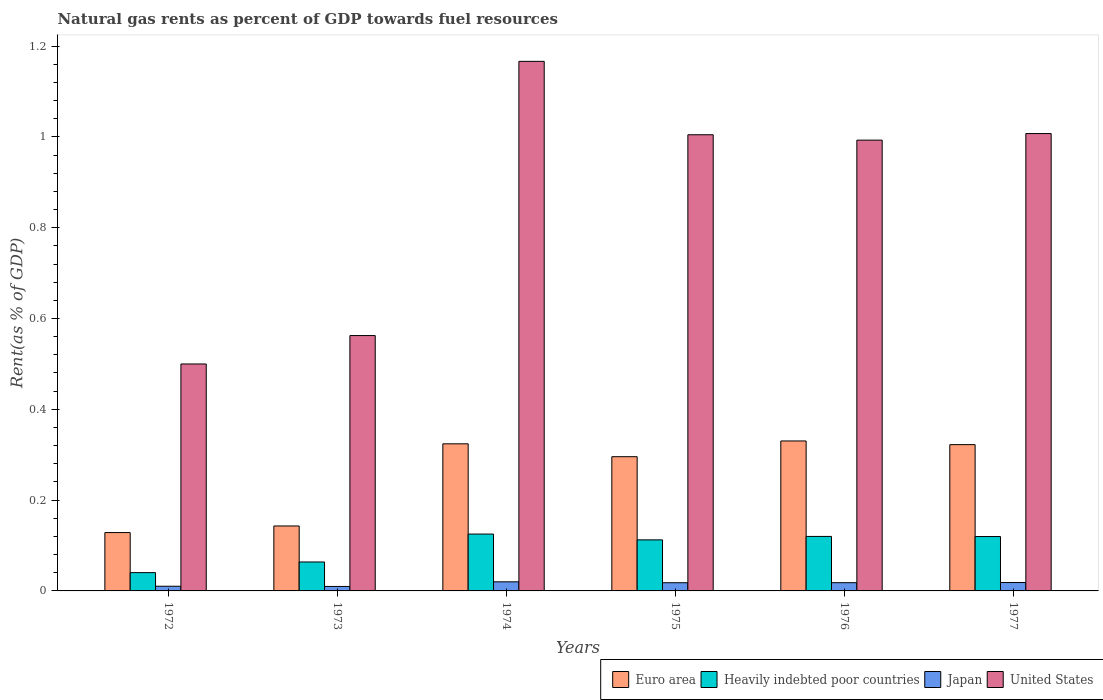How many different coloured bars are there?
Your response must be concise. 4. Are the number of bars per tick equal to the number of legend labels?
Your answer should be compact. Yes. Are the number of bars on each tick of the X-axis equal?
Provide a succinct answer. Yes. How many bars are there on the 3rd tick from the left?
Give a very brief answer. 4. What is the label of the 6th group of bars from the left?
Offer a terse response. 1977. In how many cases, is the number of bars for a given year not equal to the number of legend labels?
Provide a succinct answer. 0. What is the matural gas rent in Japan in 1975?
Your answer should be compact. 0.02. Across all years, what is the maximum matural gas rent in Japan?
Provide a succinct answer. 0.02. Across all years, what is the minimum matural gas rent in Japan?
Give a very brief answer. 0.01. In which year was the matural gas rent in Japan maximum?
Offer a terse response. 1974. In which year was the matural gas rent in Japan minimum?
Offer a very short reply. 1973. What is the total matural gas rent in Japan in the graph?
Ensure brevity in your answer.  0.09. What is the difference between the matural gas rent in Japan in 1972 and that in 1973?
Offer a very short reply. 0. What is the difference between the matural gas rent in Heavily indebted poor countries in 1974 and the matural gas rent in United States in 1972?
Offer a terse response. -0.37. What is the average matural gas rent in Heavily indebted poor countries per year?
Keep it short and to the point. 0.1. In the year 1972, what is the difference between the matural gas rent in Heavily indebted poor countries and matural gas rent in Japan?
Make the answer very short. 0.03. In how many years, is the matural gas rent in United States greater than 1.04 %?
Give a very brief answer. 1. What is the ratio of the matural gas rent in Euro area in 1973 to that in 1975?
Give a very brief answer. 0.48. Is the difference between the matural gas rent in Heavily indebted poor countries in 1973 and 1974 greater than the difference between the matural gas rent in Japan in 1973 and 1974?
Your answer should be compact. No. What is the difference between the highest and the second highest matural gas rent in Japan?
Give a very brief answer. 0. What is the difference between the highest and the lowest matural gas rent in Japan?
Ensure brevity in your answer.  0.01. Is it the case that in every year, the sum of the matural gas rent in Heavily indebted poor countries and matural gas rent in Japan is greater than the sum of matural gas rent in Euro area and matural gas rent in United States?
Offer a very short reply. Yes. What does the 2nd bar from the left in 1975 represents?
Ensure brevity in your answer.  Heavily indebted poor countries. Does the graph contain any zero values?
Your response must be concise. No. What is the title of the graph?
Your answer should be very brief. Natural gas rents as percent of GDP towards fuel resources. What is the label or title of the X-axis?
Ensure brevity in your answer.  Years. What is the label or title of the Y-axis?
Ensure brevity in your answer.  Rent(as % of GDP). What is the Rent(as % of GDP) of Euro area in 1972?
Your answer should be very brief. 0.13. What is the Rent(as % of GDP) in Heavily indebted poor countries in 1972?
Provide a succinct answer. 0.04. What is the Rent(as % of GDP) of Japan in 1972?
Your answer should be very brief. 0.01. What is the Rent(as % of GDP) of United States in 1972?
Provide a succinct answer. 0.5. What is the Rent(as % of GDP) of Euro area in 1973?
Offer a very short reply. 0.14. What is the Rent(as % of GDP) of Heavily indebted poor countries in 1973?
Provide a short and direct response. 0.06. What is the Rent(as % of GDP) of Japan in 1973?
Make the answer very short. 0.01. What is the Rent(as % of GDP) in United States in 1973?
Provide a succinct answer. 0.56. What is the Rent(as % of GDP) in Euro area in 1974?
Keep it short and to the point. 0.32. What is the Rent(as % of GDP) in Heavily indebted poor countries in 1974?
Your response must be concise. 0.13. What is the Rent(as % of GDP) in Japan in 1974?
Your answer should be very brief. 0.02. What is the Rent(as % of GDP) of United States in 1974?
Your response must be concise. 1.17. What is the Rent(as % of GDP) of Euro area in 1975?
Offer a very short reply. 0.3. What is the Rent(as % of GDP) in Heavily indebted poor countries in 1975?
Your response must be concise. 0.11. What is the Rent(as % of GDP) of Japan in 1975?
Your answer should be compact. 0.02. What is the Rent(as % of GDP) in United States in 1975?
Make the answer very short. 1. What is the Rent(as % of GDP) of Euro area in 1976?
Your answer should be compact. 0.33. What is the Rent(as % of GDP) of Heavily indebted poor countries in 1976?
Make the answer very short. 0.12. What is the Rent(as % of GDP) in Japan in 1976?
Give a very brief answer. 0.02. What is the Rent(as % of GDP) of United States in 1976?
Offer a very short reply. 0.99. What is the Rent(as % of GDP) of Euro area in 1977?
Your answer should be compact. 0.32. What is the Rent(as % of GDP) of Heavily indebted poor countries in 1977?
Your response must be concise. 0.12. What is the Rent(as % of GDP) in Japan in 1977?
Your response must be concise. 0.02. What is the Rent(as % of GDP) of United States in 1977?
Your answer should be compact. 1.01. Across all years, what is the maximum Rent(as % of GDP) in Euro area?
Ensure brevity in your answer.  0.33. Across all years, what is the maximum Rent(as % of GDP) of Heavily indebted poor countries?
Your answer should be very brief. 0.13. Across all years, what is the maximum Rent(as % of GDP) of Japan?
Make the answer very short. 0.02. Across all years, what is the maximum Rent(as % of GDP) in United States?
Provide a short and direct response. 1.17. Across all years, what is the minimum Rent(as % of GDP) in Euro area?
Offer a terse response. 0.13. Across all years, what is the minimum Rent(as % of GDP) in Heavily indebted poor countries?
Give a very brief answer. 0.04. Across all years, what is the minimum Rent(as % of GDP) in Japan?
Offer a terse response. 0.01. Across all years, what is the minimum Rent(as % of GDP) of United States?
Offer a terse response. 0.5. What is the total Rent(as % of GDP) in Euro area in the graph?
Your answer should be very brief. 1.54. What is the total Rent(as % of GDP) of Heavily indebted poor countries in the graph?
Keep it short and to the point. 0.58. What is the total Rent(as % of GDP) in Japan in the graph?
Your answer should be compact. 0.09. What is the total Rent(as % of GDP) in United States in the graph?
Your answer should be compact. 5.23. What is the difference between the Rent(as % of GDP) of Euro area in 1972 and that in 1973?
Ensure brevity in your answer.  -0.01. What is the difference between the Rent(as % of GDP) of Heavily indebted poor countries in 1972 and that in 1973?
Provide a short and direct response. -0.02. What is the difference between the Rent(as % of GDP) in United States in 1972 and that in 1973?
Your response must be concise. -0.06. What is the difference between the Rent(as % of GDP) of Euro area in 1972 and that in 1974?
Offer a terse response. -0.2. What is the difference between the Rent(as % of GDP) of Heavily indebted poor countries in 1972 and that in 1974?
Ensure brevity in your answer.  -0.09. What is the difference between the Rent(as % of GDP) in Japan in 1972 and that in 1974?
Your answer should be compact. -0.01. What is the difference between the Rent(as % of GDP) of United States in 1972 and that in 1974?
Make the answer very short. -0.67. What is the difference between the Rent(as % of GDP) in Euro area in 1972 and that in 1975?
Provide a succinct answer. -0.17. What is the difference between the Rent(as % of GDP) of Heavily indebted poor countries in 1972 and that in 1975?
Offer a terse response. -0.07. What is the difference between the Rent(as % of GDP) of Japan in 1972 and that in 1975?
Your answer should be compact. -0.01. What is the difference between the Rent(as % of GDP) in United States in 1972 and that in 1975?
Provide a short and direct response. -0.5. What is the difference between the Rent(as % of GDP) of Euro area in 1972 and that in 1976?
Your answer should be compact. -0.2. What is the difference between the Rent(as % of GDP) in Heavily indebted poor countries in 1972 and that in 1976?
Provide a succinct answer. -0.08. What is the difference between the Rent(as % of GDP) in Japan in 1972 and that in 1976?
Your response must be concise. -0.01. What is the difference between the Rent(as % of GDP) in United States in 1972 and that in 1976?
Make the answer very short. -0.49. What is the difference between the Rent(as % of GDP) in Euro area in 1972 and that in 1977?
Keep it short and to the point. -0.19. What is the difference between the Rent(as % of GDP) in Heavily indebted poor countries in 1972 and that in 1977?
Offer a very short reply. -0.08. What is the difference between the Rent(as % of GDP) in Japan in 1972 and that in 1977?
Your response must be concise. -0.01. What is the difference between the Rent(as % of GDP) of United States in 1972 and that in 1977?
Your response must be concise. -0.51. What is the difference between the Rent(as % of GDP) in Euro area in 1973 and that in 1974?
Your answer should be very brief. -0.18. What is the difference between the Rent(as % of GDP) of Heavily indebted poor countries in 1973 and that in 1974?
Your answer should be very brief. -0.06. What is the difference between the Rent(as % of GDP) in Japan in 1973 and that in 1974?
Your answer should be very brief. -0.01. What is the difference between the Rent(as % of GDP) of United States in 1973 and that in 1974?
Your response must be concise. -0.6. What is the difference between the Rent(as % of GDP) of Euro area in 1973 and that in 1975?
Provide a succinct answer. -0.15. What is the difference between the Rent(as % of GDP) of Heavily indebted poor countries in 1973 and that in 1975?
Provide a short and direct response. -0.05. What is the difference between the Rent(as % of GDP) of Japan in 1973 and that in 1975?
Provide a short and direct response. -0.01. What is the difference between the Rent(as % of GDP) of United States in 1973 and that in 1975?
Ensure brevity in your answer.  -0.44. What is the difference between the Rent(as % of GDP) of Euro area in 1973 and that in 1976?
Provide a short and direct response. -0.19. What is the difference between the Rent(as % of GDP) in Heavily indebted poor countries in 1973 and that in 1976?
Keep it short and to the point. -0.06. What is the difference between the Rent(as % of GDP) of Japan in 1973 and that in 1976?
Provide a succinct answer. -0.01. What is the difference between the Rent(as % of GDP) in United States in 1973 and that in 1976?
Ensure brevity in your answer.  -0.43. What is the difference between the Rent(as % of GDP) of Euro area in 1973 and that in 1977?
Make the answer very short. -0.18. What is the difference between the Rent(as % of GDP) in Heavily indebted poor countries in 1973 and that in 1977?
Make the answer very short. -0.06. What is the difference between the Rent(as % of GDP) in Japan in 1973 and that in 1977?
Provide a succinct answer. -0.01. What is the difference between the Rent(as % of GDP) of United States in 1973 and that in 1977?
Make the answer very short. -0.44. What is the difference between the Rent(as % of GDP) of Euro area in 1974 and that in 1975?
Offer a very short reply. 0.03. What is the difference between the Rent(as % of GDP) of Heavily indebted poor countries in 1974 and that in 1975?
Ensure brevity in your answer.  0.01. What is the difference between the Rent(as % of GDP) in Japan in 1974 and that in 1975?
Keep it short and to the point. 0. What is the difference between the Rent(as % of GDP) of United States in 1974 and that in 1975?
Ensure brevity in your answer.  0.16. What is the difference between the Rent(as % of GDP) in Euro area in 1974 and that in 1976?
Your answer should be very brief. -0.01. What is the difference between the Rent(as % of GDP) of Heavily indebted poor countries in 1974 and that in 1976?
Your response must be concise. 0.01. What is the difference between the Rent(as % of GDP) in Japan in 1974 and that in 1976?
Your answer should be very brief. 0. What is the difference between the Rent(as % of GDP) of United States in 1974 and that in 1976?
Your response must be concise. 0.17. What is the difference between the Rent(as % of GDP) in Euro area in 1974 and that in 1977?
Offer a terse response. 0. What is the difference between the Rent(as % of GDP) in Heavily indebted poor countries in 1974 and that in 1977?
Offer a very short reply. 0.01. What is the difference between the Rent(as % of GDP) in Japan in 1974 and that in 1977?
Your response must be concise. 0. What is the difference between the Rent(as % of GDP) of United States in 1974 and that in 1977?
Keep it short and to the point. 0.16. What is the difference between the Rent(as % of GDP) of Euro area in 1975 and that in 1976?
Ensure brevity in your answer.  -0.03. What is the difference between the Rent(as % of GDP) in Heavily indebted poor countries in 1975 and that in 1976?
Provide a succinct answer. -0.01. What is the difference between the Rent(as % of GDP) in United States in 1975 and that in 1976?
Your answer should be compact. 0.01. What is the difference between the Rent(as % of GDP) of Euro area in 1975 and that in 1977?
Ensure brevity in your answer.  -0.03. What is the difference between the Rent(as % of GDP) in Heavily indebted poor countries in 1975 and that in 1977?
Ensure brevity in your answer.  -0.01. What is the difference between the Rent(as % of GDP) in Japan in 1975 and that in 1977?
Your answer should be very brief. -0. What is the difference between the Rent(as % of GDP) of United States in 1975 and that in 1977?
Provide a short and direct response. -0. What is the difference between the Rent(as % of GDP) in Euro area in 1976 and that in 1977?
Your answer should be compact. 0.01. What is the difference between the Rent(as % of GDP) of Heavily indebted poor countries in 1976 and that in 1977?
Your answer should be compact. 0. What is the difference between the Rent(as % of GDP) in Japan in 1976 and that in 1977?
Provide a succinct answer. -0. What is the difference between the Rent(as % of GDP) in United States in 1976 and that in 1977?
Keep it short and to the point. -0.01. What is the difference between the Rent(as % of GDP) in Euro area in 1972 and the Rent(as % of GDP) in Heavily indebted poor countries in 1973?
Ensure brevity in your answer.  0.06. What is the difference between the Rent(as % of GDP) of Euro area in 1972 and the Rent(as % of GDP) of Japan in 1973?
Make the answer very short. 0.12. What is the difference between the Rent(as % of GDP) in Euro area in 1972 and the Rent(as % of GDP) in United States in 1973?
Your answer should be very brief. -0.43. What is the difference between the Rent(as % of GDP) of Heavily indebted poor countries in 1972 and the Rent(as % of GDP) of Japan in 1973?
Give a very brief answer. 0.03. What is the difference between the Rent(as % of GDP) in Heavily indebted poor countries in 1972 and the Rent(as % of GDP) in United States in 1973?
Your answer should be compact. -0.52. What is the difference between the Rent(as % of GDP) in Japan in 1972 and the Rent(as % of GDP) in United States in 1973?
Ensure brevity in your answer.  -0.55. What is the difference between the Rent(as % of GDP) in Euro area in 1972 and the Rent(as % of GDP) in Heavily indebted poor countries in 1974?
Provide a short and direct response. 0. What is the difference between the Rent(as % of GDP) of Euro area in 1972 and the Rent(as % of GDP) of Japan in 1974?
Keep it short and to the point. 0.11. What is the difference between the Rent(as % of GDP) of Euro area in 1972 and the Rent(as % of GDP) of United States in 1974?
Provide a short and direct response. -1.04. What is the difference between the Rent(as % of GDP) in Heavily indebted poor countries in 1972 and the Rent(as % of GDP) in Japan in 1974?
Provide a succinct answer. 0.02. What is the difference between the Rent(as % of GDP) of Heavily indebted poor countries in 1972 and the Rent(as % of GDP) of United States in 1974?
Offer a terse response. -1.13. What is the difference between the Rent(as % of GDP) of Japan in 1972 and the Rent(as % of GDP) of United States in 1974?
Provide a succinct answer. -1.16. What is the difference between the Rent(as % of GDP) of Euro area in 1972 and the Rent(as % of GDP) of Heavily indebted poor countries in 1975?
Make the answer very short. 0.02. What is the difference between the Rent(as % of GDP) in Euro area in 1972 and the Rent(as % of GDP) in Japan in 1975?
Provide a short and direct response. 0.11. What is the difference between the Rent(as % of GDP) of Euro area in 1972 and the Rent(as % of GDP) of United States in 1975?
Your response must be concise. -0.88. What is the difference between the Rent(as % of GDP) in Heavily indebted poor countries in 1972 and the Rent(as % of GDP) in Japan in 1975?
Your answer should be compact. 0.02. What is the difference between the Rent(as % of GDP) in Heavily indebted poor countries in 1972 and the Rent(as % of GDP) in United States in 1975?
Your answer should be very brief. -0.96. What is the difference between the Rent(as % of GDP) of Japan in 1972 and the Rent(as % of GDP) of United States in 1975?
Ensure brevity in your answer.  -0.99. What is the difference between the Rent(as % of GDP) of Euro area in 1972 and the Rent(as % of GDP) of Heavily indebted poor countries in 1976?
Keep it short and to the point. 0.01. What is the difference between the Rent(as % of GDP) in Euro area in 1972 and the Rent(as % of GDP) in Japan in 1976?
Ensure brevity in your answer.  0.11. What is the difference between the Rent(as % of GDP) of Euro area in 1972 and the Rent(as % of GDP) of United States in 1976?
Offer a terse response. -0.86. What is the difference between the Rent(as % of GDP) of Heavily indebted poor countries in 1972 and the Rent(as % of GDP) of Japan in 1976?
Make the answer very short. 0.02. What is the difference between the Rent(as % of GDP) in Heavily indebted poor countries in 1972 and the Rent(as % of GDP) in United States in 1976?
Keep it short and to the point. -0.95. What is the difference between the Rent(as % of GDP) of Japan in 1972 and the Rent(as % of GDP) of United States in 1976?
Provide a succinct answer. -0.98. What is the difference between the Rent(as % of GDP) in Euro area in 1972 and the Rent(as % of GDP) in Heavily indebted poor countries in 1977?
Give a very brief answer. 0.01. What is the difference between the Rent(as % of GDP) of Euro area in 1972 and the Rent(as % of GDP) of Japan in 1977?
Make the answer very short. 0.11. What is the difference between the Rent(as % of GDP) in Euro area in 1972 and the Rent(as % of GDP) in United States in 1977?
Make the answer very short. -0.88. What is the difference between the Rent(as % of GDP) in Heavily indebted poor countries in 1972 and the Rent(as % of GDP) in Japan in 1977?
Provide a short and direct response. 0.02. What is the difference between the Rent(as % of GDP) in Heavily indebted poor countries in 1972 and the Rent(as % of GDP) in United States in 1977?
Your answer should be compact. -0.97. What is the difference between the Rent(as % of GDP) in Japan in 1972 and the Rent(as % of GDP) in United States in 1977?
Your answer should be very brief. -1. What is the difference between the Rent(as % of GDP) of Euro area in 1973 and the Rent(as % of GDP) of Heavily indebted poor countries in 1974?
Offer a very short reply. 0.02. What is the difference between the Rent(as % of GDP) in Euro area in 1973 and the Rent(as % of GDP) in Japan in 1974?
Ensure brevity in your answer.  0.12. What is the difference between the Rent(as % of GDP) of Euro area in 1973 and the Rent(as % of GDP) of United States in 1974?
Offer a very short reply. -1.02. What is the difference between the Rent(as % of GDP) of Heavily indebted poor countries in 1973 and the Rent(as % of GDP) of Japan in 1974?
Your answer should be very brief. 0.04. What is the difference between the Rent(as % of GDP) of Heavily indebted poor countries in 1973 and the Rent(as % of GDP) of United States in 1974?
Your response must be concise. -1.1. What is the difference between the Rent(as % of GDP) of Japan in 1973 and the Rent(as % of GDP) of United States in 1974?
Offer a terse response. -1.16. What is the difference between the Rent(as % of GDP) of Euro area in 1973 and the Rent(as % of GDP) of Heavily indebted poor countries in 1975?
Give a very brief answer. 0.03. What is the difference between the Rent(as % of GDP) of Euro area in 1973 and the Rent(as % of GDP) of United States in 1975?
Provide a short and direct response. -0.86. What is the difference between the Rent(as % of GDP) of Heavily indebted poor countries in 1973 and the Rent(as % of GDP) of Japan in 1975?
Make the answer very short. 0.05. What is the difference between the Rent(as % of GDP) in Heavily indebted poor countries in 1973 and the Rent(as % of GDP) in United States in 1975?
Your answer should be compact. -0.94. What is the difference between the Rent(as % of GDP) in Japan in 1973 and the Rent(as % of GDP) in United States in 1975?
Ensure brevity in your answer.  -0.99. What is the difference between the Rent(as % of GDP) in Euro area in 1973 and the Rent(as % of GDP) in Heavily indebted poor countries in 1976?
Your response must be concise. 0.02. What is the difference between the Rent(as % of GDP) of Euro area in 1973 and the Rent(as % of GDP) of Japan in 1976?
Provide a succinct answer. 0.12. What is the difference between the Rent(as % of GDP) in Euro area in 1973 and the Rent(as % of GDP) in United States in 1976?
Keep it short and to the point. -0.85. What is the difference between the Rent(as % of GDP) of Heavily indebted poor countries in 1973 and the Rent(as % of GDP) of Japan in 1976?
Give a very brief answer. 0.05. What is the difference between the Rent(as % of GDP) of Heavily indebted poor countries in 1973 and the Rent(as % of GDP) of United States in 1976?
Keep it short and to the point. -0.93. What is the difference between the Rent(as % of GDP) in Japan in 1973 and the Rent(as % of GDP) in United States in 1976?
Give a very brief answer. -0.98. What is the difference between the Rent(as % of GDP) in Euro area in 1973 and the Rent(as % of GDP) in Heavily indebted poor countries in 1977?
Your response must be concise. 0.02. What is the difference between the Rent(as % of GDP) in Euro area in 1973 and the Rent(as % of GDP) in Japan in 1977?
Provide a succinct answer. 0.12. What is the difference between the Rent(as % of GDP) of Euro area in 1973 and the Rent(as % of GDP) of United States in 1977?
Your response must be concise. -0.86. What is the difference between the Rent(as % of GDP) in Heavily indebted poor countries in 1973 and the Rent(as % of GDP) in Japan in 1977?
Give a very brief answer. 0.05. What is the difference between the Rent(as % of GDP) of Heavily indebted poor countries in 1973 and the Rent(as % of GDP) of United States in 1977?
Your answer should be very brief. -0.94. What is the difference between the Rent(as % of GDP) in Japan in 1973 and the Rent(as % of GDP) in United States in 1977?
Give a very brief answer. -1. What is the difference between the Rent(as % of GDP) in Euro area in 1974 and the Rent(as % of GDP) in Heavily indebted poor countries in 1975?
Offer a terse response. 0.21. What is the difference between the Rent(as % of GDP) of Euro area in 1974 and the Rent(as % of GDP) of Japan in 1975?
Your answer should be very brief. 0.31. What is the difference between the Rent(as % of GDP) in Euro area in 1974 and the Rent(as % of GDP) in United States in 1975?
Give a very brief answer. -0.68. What is the difference between the Rent(as % of GDP) in Heavily indebted poor countries in 1974 and the Rent(as % of GDP) in Japan in 1975?
Provide a short and direct response. 0.11. What is the difference between the Rent(as % of GDP) in Heavily indebted poor countries in 1974 and the Rent(as % of GDP) in United States in 1975?
Make the answer very short. -0.88. What is the difference between the Rent(as % of GDP) in Japan in 1974 and the Rent(as % of GDP) in United States in 1975?
Provide a short and direct response. -0.98. What is the difference between the Rent(as % of GDP) of Euro area in 1974 and the Rent(as % of GDP) of Heavily indebted poor countries in 1976?
Give a very brief answer. 0.2. What is the difference between the Rent(as % of GDP) in Euro area in 1974 and the Rent(as % of GDP) in Japan in 1976?
Provide a short and direct response. 0.31. What is the difference between the Rent(as % of GDP) of Euro area in 1974 and the Rent(as % of GDP) of United States in 1976?
Make the answer very short. -0.67. What is the difference between the Rent(as % of GDP) of Heavily indebted poor countries in 1974 and the Rent(as % of GDP) of Japan in 1976?
Your answer should be very brief. 0.11. What is the difference between the Rent(as % of GDP) in Heavily indebted poor countries in 1974 and the Rent(as % of GDP) in United States in 1976?
Keep it short and to the point. -0.87. What is the difference between the Rent(as % of GDP) in Japan in 1974 and the Rent(as % of GDP) in United States in 1976?
Provide a succinct answer. -0.97. What is the difference between the Rent(as % of GDP) of Euro area in 1974 and the Rent(as % of GDP) of Heavily indebted poor countries in 1977?
Give a very brief answer. 0.2. What is the difference between the Rent(as % of GDP) of Euro area in 1974 and the Rent(as % of GDP) of Japan in 1977?
Provide a short and direct response. 0.31. What is the difference between the Rent(as % of GDP) of Euro area in 1974 and the Rent(as % of GDP) of United States in 1977?
Provide a short and direct response. -0.68. What is the difference between the Rent(as % of GDP) in Heavily indebted poor countries in 1974 and the Rent(as % of GDP) in Japan in 1977?
Keep it short and to the point. 0.11. What is the difference between the Rent(as % of GDP) in Heavily indebted poor countries in 1974 and the Rent(as % of GDP) in United States in 1977?
Provide a succinct answer. -0.88. What is the difference between the Rent(as % of GDP) of Japan in 1974 and the Rent(as % of GDP) of United States in 1977?
Your response must be concise. -0.99. What is the difference between the Rent(as % of GDP) of Euro area in 1975 and the Rent(as % of GDP) of Heavily indebted poor countries in 1976?
Your answer should be very brief. 0.18. What is the difference between the Rent(as % of GDP) in Euro area in 1975 and the Rent(as % of GDP) in Japan in 1976?
Provide a short and direct response. 0.28. What is the difference between the Rent(as % of GDP) of Euro area in 1975 and the Rent(as % of GDP) of United States in 1976?
Provide a succinct answer. -0.7. What is the difference between the Rent(as % of GDP) of Heavily indebted poor countries in 1975 and the Rent(as % of GDP) of Japan in 1976?
Your answer should be very brief. 0.09. What is the difference between the Rent(as % of GDP) in Heavily indebted poor countries in 1975 and the Rent(as % of GDP) in United States in 1976?
Provide a succinct answer. -0.88. What is the difference between the Rent(as % of GDP) of Japan in 1975 and the Rent(as % of GDP) of United States in 1976?
Offer a very short reply. -0.97. What is the difference between the Rent(as % of GDP) of Euro area in 1975 and the Rent(as % of GDP) of Heavily indebted poor countries in 1977?
Provide a short and direct response. 0.18. What is the difference between the Rent(as % of GDP) in Euro area in 1975 and the Rent(as % of GDP) in Japan in 1977?
Your answer should be compact. 0.28. What is the difference between the Rent(as % of GDP) in Euro area in 1975 and the Rent(as % of GDP) in United States in 1977?
Ensure brevity in your answer.  -0.71. What is the difference between the Rent(as % of GDP) in Heavily indebted poor countries in 1975 and the Rent(as % of GDP) in Japan in 1977?
Give a very brief answer. 0.09. What is the difference between the Rent(as % of GDP) of Heavily indebted poor countries in 1975 and the Rent(as % of GDP) of United States in 1977?
Provide a succinct answer. -0.89. What is the difference between the Rent(as % of GDP) of Japan in 1975 and the Rent(as % of GDP) of United States in 1977?
Make the answer very short. -0.99. What is the difference between the Rent(as % of GDP) in Euro area in 1976 and the Rent(as % of GDP) in Heavily indebted poor countries in 1977?
Make the answer very short. 0.21. What is the difference between the Rent(as % of GDP) of Euro area in 1976 and the Rent(as % of GDP) of Japan in 1977?
Offer a very short reply. 0.31. What is the difference between the Rent(as % of GDP) of Euro area in 1976 and the Rent(as % of GDP) of United States in 1977?
Offer a very short reply. -0.68. What is the difference between the Rent(as % of GDP) in Heavily indebted poor countries in 1976 and the Rent(as % of GDP) in Japan in 1977?
Make the answer very short. 0.1. What is the difference between the Rent(as % of GDP) in Heavily indebted poor countries in 1976 and the Rent(as % of GDP) in United States in 1977?
Provide a succinct answer. -0.89. What is the difference between the Rent(as % of GDP) of Japan in 1976 and the Rent(as % of GDP) of United States in 1977?
Offer a terse response. -0.99. What is the average Rent(as % of GDP) in Euro area per year?
Keep it short and to the point. 0.26. What is the average Rent(as % of GDP) of Heavily indebted poor countries per year?
Give a very brief answer. 0.1. What is the average Rent(as % of GDP) in Japan per year?
Your response must be concise. 0.02. What is the average Rent(as % of GDP) in United States per year?
Your answer should be compact. 0.87. In the year 1972, what is the difference between the Rent(as % of GDP) in Euro area and Rent(as % of GDP) in Heavily indebted poor countries?
Ensure brevity in your answer.  0.09. In the year 1972, what is the difference between the Rent(as % of GDP) of Euro area and Rent(as % of GDP) of Japan?
Your answer should be very brief. 0.12. In the year 1972, what is the difference between the Rent(as % of GDP) in Euro area and Rent(as % of GDP) in United States?
Give a very brief answer. -0.37. In the year 1972, what is the difference between the Rent(as % of GDP) in Heavily indebted poor countries and Rent(as % of GDP) in Japan?
Provide a short and direct response. 0.03. In the year 1972, what is the difference between the Rent(as % of GDP) in Heavily indebted poor countries and Rent(as % of GDP) in United States?
Ensure brevity in your answer.  -0.46. In the year 1972, what is the difference between the Rent(as % of GDP) of Japan and Rent(as % of GDP) of United States?
Your response must be concise. -0.49. In the year 1973, what is the difference between the Rent(as % of GDP) of Euro area and Rent(as % of GDP) of Heavily indebted poor countries?
Your answer should be very brief. 0.08. In the year 1973, what is the difference between the Rent(as % of GDP) in Euro area and Rent(as % of GDP) in Japan?
Make the answer very short. 0.13. In the year 1973, what is the difference between the Rent(as % of GDP) in Euro area and Rent(as % of GDP) in United States?
Keep it short and to the point. -0.42. In the year 1973, what is the difference between the Rent(as % of GDP) of Heavily indebted poor countries and Rent(as % of GDP) of Japan?
Ensure brevity in your answer.  0.05. In the year 1973, what is the difference between the Rent(as % of GDP) of Heavily indebted poor countries and Rent(as % of GDP) of United States?
Keep it short and to the point. -0.5. In the year 1973, what is the difference between the Rent(as % of GDP) in Japan and Rent(as % of GDP) in United States?
Your answer should be very brief. -0.55. In the year 1974, what is the difference between the Rent(as % of GDP) of Euro area and Rent(as % of GDP) of Heavily indebted poor countries?
Provide a short and direct response. 0.2. In the year 1974, what is the difference between the Rent(as % of GDP) of Euro area and Rent(as % of GDP) of Japan?
Offer a terse response. 0.3. In the year 1974, what is the difference between the Rent(as % of GDP) in Euro area and Rent(as % of GDP) in United States?
Keep it short and to the point. -0.84. In the year 1974, what is the difference between the Rent(as % of GDP) of Heavily indebted poor countries and Rent(as % of GDP) of Japan?
Provide a short and direct response. 0.11. In the year 1974, what is the difference between the Rent(as % of GDP) in Heavily indebted poor countries and Rent(as % of GDP) in United States?
Your answer should be compact. -1.04. In the year 1974, what is the difference between the Rent(as % of GDP) in Japan and Rent(as % of GDP) in United States?
Your answer should be very brief. -1.15. In the year 1975, what is the difference between the Rent(as % of GDP) in Euro area and Rent(as % of GDP) in Heavily indebted poor countries?
Offer a very short reply. 0.18. In the year 1975, what is the difference between the Rent(as % of GDP) in Euro area and Rent(as % of GDP) in Japan?
Your answer should be very brief. 0.28. In the year 1975, what is the difference between the Rent(as % of GDP) of Euro area and Rent(as % of GDP) of United States?
Provide a short and direct response. -0.71. In the year 1975, what is the difference between the Rent(as % of GDP) of Heavily indebted poor countries and Rent(as % of GDP) of Japan?
Your response must be concise. 0.09. In the year 1975, what is the difference between the Rent(as % of GDP) in Heavily indebted poor countries and Rent(as % of GDP) in United States?
Your answer should be very brief. -0.89. In the year 1975, what is the difference between the Rent(as % of GDP) in Japan and Rent(as % of GDP) in United States?
Your response must be concise. -0.99. In the year 1976, what is the difference between the Rent(as % of GDP) in Euro area and Rent(as % of GDP) in Heavily indebted poor countries?
Offer a terse response. 0.21. In the year 1976, what is the difference between the Rent(as % of GDP) of Euro area and Rent(as % of GDP) of Japan?
Ensure brevity in your answer.  0.31. In the year 1976, what is the difference between the Rent(as % of GDP) of Euro area and Rent(as % of GDP) of United States?
Make the answer very short. -0.66. In the year 1976, what is the difference between the Rent(as % of GDP) of Heavily indebted poor countries and Rent(as % of GDP) of Japan?
Provide a short and direct response. 0.1. In the year 1976, what is the difference between the Rent(as % of GDP) in Heavily indebted poor countries and Rent(as % of GDP) in United States?
Ensure brevity in your answer.  -0.87. In the year 1976, what is the difference between the Rent(as % of GDP) of Japan and Rent(as % of GDP) of United States?
Your answer should be very brief. -0.97. In the year 1977, what is the difference between the Rent(as % of GDP) in Euro area and Rent(as % of GDP) in Heavily indebted poor countries?
Give a very brief answer. 0.2. In the year 1977, what is the difference between the Rent(as % of GDP) of Euro area and Rent(as % of GDP) of Japan?
Your answer should be compact. 0.3. In the year 1977, what is the difference between the Rent(as % of GDP) in Euro area and Rent(as % of GDP) in United States?
Make the answer very short. -0.69. In the year 1977, what is the difference between the Rent(as % of GDP) in Heavily indebted poor countries and Rent(as % of GDP) in Japan?
Provide a short and direct response. 0.1. In the year 1977, what is the difference between the Rent(as % of GDP) of Heavily indebted poor countries and Rent(as % of GDP) of United States?
Offer a terse response. -0.89. In the year 1977, what is the difference between the Rent(as % of GDP) of Japan and Rent(as % of GDP) of United States?
Give a very brief answer. -0.99. What is the ratio of the Rent(as % of GDP) in Euro area in 1972 to that in 1973?
Ensure brevity in your answer.  0.9. What is the ratio of the Rent(as % of GDP) of Heavily indebted poor countries in 1972 to that in 1973?
Your answer should be very brief. 0.63. What is the ratio of the Rent(as % of GDP) of Japan in 1972 to that in 1973?
Ensure brevity in your answer.  1.04. What is the ratio of the Rent(as % of GDP) of United States in 1972 to that in 1973?
Keep it short and to the point. 0.89. What is the ratio of the Rent(as % of GDP) in Euro area in 1972 to that in 1974?
Offer a very short reply. 0.4. What is the ratio of the Rent(as % of GDP) of Heavily indebted poor countries in 1972 to that in 1974?
Offer a terse response. 0.32. What is the ratio of the Rent(as % of GDP) in Japan in 1972 to that in 1974?
Give a very brief answer. 0.51. What is the ratio of the Rent(as % of GDP) in United States in 1972 to that in 1974?
Provide a succinct answer. 0.43. What is the ratio of the Rent(as % of GDP) in Euro area in 1972 to that in 1975?
Offer a very short reply. 0.43. What is the ratio of the Rent(as % of GDP) of Heavily indebted poor countries in 1972 to that in 1975?
Offer a terse response. 0.36. What is the ratio of the Rent(as % of GDP) in Japan in 1972 to that in 1975?
Your response must be concise. 0.57. What is the ratio of the Rent(as % of GDP) in United States in 1972 to that in 1975?
Give a very brief answer. 0.5. What is the ratio of the Rent(as % of GDP) in Euro area in 1972 to that in 1976?
Your answer should be compact. 0.39. What is the ratio of the Rent(as % of GDP) in Heavily indebted poor countries in 1972 to that in 1976?
Keep it short and to the point. 0.34. What is the ratio of the Rent(as % of GDP) in Japan in 1972 to that in 1976?
Ensure brevity in your answer.  0.57. What is the ratio of the Rent(as % of GDP) in United States in 1972 to that in 1976?
Your response must be concise. 0.5. What is the ratio of the Rent(as % of GDP) in Euro area in 1972 to that in 1977?
Your answer should be very brief. 0.4. What is the ratio of the Rent(as % of GDP) in Heavily indebted poor countries in 1972 to that in 1977?
Offer a terse response. 0.34. What is the ratio of the Rent(as % of GDP) of Japan in 1972 to that in 1977?
Offer a very short reply. 0.56. What is the ratio of the Rent(as % of GDP) in United States in 1972 to that in 1977?
Give a very brief answer. 0.5. What is the ratio of the Rent(as % of GDP) in Euro area in 1973 to that in 1974?
Provide a short and direct response. 0.44. What is the ratio of the Rent(as % of GDP) of Heavily indebted poor countries in 1973 to that in 1974?
Provide a short and direct response. 0.51. What is the ratio of the Rent(as % of GDP) in Japan in 1973 to that in 1974?
Offer a very short reply. 0.49. What is the ratio of the Rent(as % of GDP) of United States in 1973 to that in 1974?
Offer a very short reply. 0.48. What is the ratio of the Rent(as % of GDP) in Euro area in 1973 to that in 1975?
Provide a short and direct response. 0.48. What is the ratio of the Rent(as % of GDP) of Heavily indebted poor countries in 1973 to that in 1975?
Keep it short and to the point. 0.57. What is the ratio of the Rent(as % of GDP) in Japan in 1973 to that in 1975?
Your answer should be compact. 0.55. What is the ratio of the Rent(as % of GDP) of United States in 1973 to that in 1975?
Keep it short and to the point. 0.56. What is the ratio of the Rent(as % of GDP) in Euro area in 1973 to that in 1976?
Your answer should be very brief. 0.43. What is the ratio of the Rent(as % of GDP) in Heavily indebted poor countries in 1973 to that in 1976?
Provide a short and direct response. 0.53. What is the ratio of the Rent(as % of GDP) in Japan in 1973 to that in 1976?
Ensure brevity in your answer.  0.54. What is the ratio of the Rent(as % of GDP) of United States in 1973 to that in 1976?
Offer a very short reply. 0.57. What is the ratio of the Rent(as % of GDP) in Euro area in 1973 to that in 1977?
Your response must be concise. 0.44. What is the ratio of the Rent(as % of GDP) of Heavily indebted poor countries in 1973 to that in 1977?
Provide a succinct answer. 0.53. What is the ratio of the Rent(as % of GDP) in Japan in 1973 to that in 1977?
Your response must be concise. 0.53. What is the ratio of the Rent(as % of GDP) in United States in 1973 to that in 1977?
Offer a terse response. 0.56. What is the ratio of the Rent(as % of GDP) in Euro area in 1974 to that in 1975?
Your response must be concise. 1.1. What is the ratio of the Rent(as % of GDP) in Heavily indebted poor countries in 1974 to that in 1975?
Your response must be concise. 1.11. What is the ratio of the Rent(as % of GDP) in Japan in 1974 to that in 1975?
Offer a very short reply. 1.11. What is the ratio of the Rent(as % of GDP) in United States in 1974 to that in 1975?
Keep it short and to the point. 1.16. What is the ratio of the Rent(as % of GDP) of Euro area in 1974 to that in 1976?
Your response must be concise. 0.98. What is the ratio of the Rent(as % of GDP) in Heavily indebted poor countries in 1974 to that in 1976?
Offer a terse response. 1.04. What is the ratio of the Rent(as % of GDP) of Japan in 1974 to that in 1976?
Ensure brevity in your answer.  1.11. What is the ratio of the Rent(as % of GDP) of United States in 1974 to that in 1976?
Keep it short and to the point. 1.17. What is the ratio of the Rent(as % of GDP) in Heavily indebted poor countries in 1974 to that in 1977?
Provide a succinct answer. 1.05. What is the ratio of the Rent(as % of GDP) of Japan in 1974 to that in 1977?
Provide a short and direct response. 1.08. What is the ratio of the Rent(as % of GDP) in United States in 1974 to that in 1977?
Make the answer very short. 1.16. What is the ratio of the Rent(as % of GDP) of Euro area in 1975 to that in 1976?
Make the answer very short. 0.9. What is the ratio of the Rent(as % of GDP) in Heavily indebted poor countries in 1975 to that in 1976?
Provide a short and direct response. 0.94. What is the ratio of the Rent(as % of GDP) of United States in 1975 to that in 1976?
Your answer should be very brief. 1.01. What is the ratio of the Rent(as % of GDP) in Euro area in 1975 to that in 1977?
Keep it short and to the point. 0.92. What is the ratio of the Rent(as % of GDP) of Heavily indebted poor countries in 1975 to that in 1977?
Provide a short and direct response. 0.94. What is the ratio of the Rent(as % of GDP) of Japan in 1975 to that in 1977?
Your answer should be very brief. 0.98. What is the ratio of the Rent(as % of GDP) in Euro area in 1976 to that in 1977?
Offer a terse response. 1.03. What is the ratio of the Rent(as % of GDP) of Heavily indebted poor countries in 1976 to that in 1977?
Provide a succinct answer. 1. What is the ratio of the Rent(as % of GDP) of Japan in 1976 to that in 1977?
Provide a succinct answer. 0.98. What is the ratio of the Rent(as % of GDP) of United States in 1976 to that in 1977?
Keep it short and to the point. 0.99. What is the difference between the highest and the second highest Rent(as % of GDP) of Euro area?
Provide a short and direct response. 0.01. What is the difference between the highest and the second highest Rent(as % of GDP) of Heavily indebted poor countries?
Your response must be concise. 0.01. What is the difference between the highest and the second highest Rent(as % of GDP) in Japan?
Give a very brief answer. 0. What is the difference between the highest and the second highest Rent(as % of GDP) of United States?
Offer a terse response. 0.16. What is the difference between the highest and the lowest Rent(as % of GDP) in Euro area?
Ensure brevity in your answer.  0.2. What is the difference between the highest and the lowest Rent(as % of GDP) in Heavily indebted poor countries?
Make the answer very short. 0.09. What is the difference between the highest and the lowest Rent(as % of GDP) in Japan?
Provide a succinct answer. 0.01. What is the difference between the highest and the lowest Rent(as % of GDP) of United States?
Provide a succinct answer. 0.67. 